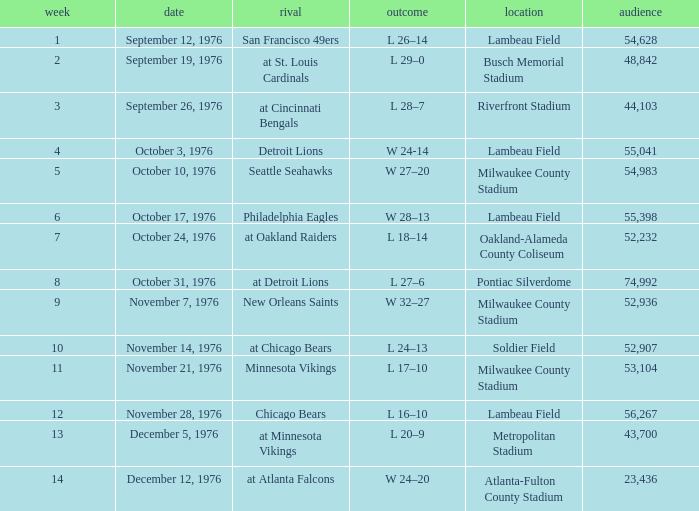Give me the full table as a dictionary. {'header': ['week', 'date', 'rival', 'outcome', 'location', 'audience'], 'rows': [['1', 'September 12, 1976', 'San Francisco 49ers', 'L 26–14', 'Lambeau Field', '54,628'], ['2', 'September 19, 1976', 'at St. Louis Cardinals', 'L 29–0', 'Busch Memorial Stadium', '48,842'], ['3', 'September 26, 1976', 'at Cincinnati Bengals', 'L 28–7', 'Riverfront Stadium', '44,103'], ['4', 'October 3, 1976', 'Detroit Lions', 'W 24-14', 'Lambeau Field', '55,041'], ['5', 'October 10, 1976', 'Seattle Seahawks', 'W 27–20', 'Milwaukee County Stadium', '54,983'], ['6', 'October 17, 1976', 'Philadelphia Eagles', 'W 28–13', 'Lambeau Field', '55,398'], ['7', 'October 24, 1976', 'at Oakland Raiders', 'L 18–14', 'Oakland-Alameda County Coliseum', '52,232'], ['8', 'October 31, 1976', 'at Detroit Lions', 'L 27–6', 'Pontiac Silverdome', '74,992'], ['9', 'November 7, 1976', 'New Orleans Saints', 'W 32–27', 'Milwaukee County Stadium', '52,936'], ['10', 'November 14, 1976', 'at Chicago Bears', 'L 24–13', 'Soldier Field', '52,907'], ['11', 'November 21, 1976', 'Minnesota Vikings', 'L 17–10', 'Milwaukee County Stadium', '53,104'], ['12', 'November 28, 1976', 'Chicago Bears', 'L 16–10', 'Lambeau Field', '56,267'], ['13', 'December 5, 1976', 'at Minnesota Vikings', 'L 20–9', 'Metropolitan Stadium', '43,700'], ['14', 'December 12, 1976', 'at Atlanta Falcons', 'W 24–20', 'Atlanta-Fulton County Stadium', '23,436']]} What is the lowest week number where they played against the Detroit Lions? 4.0. 